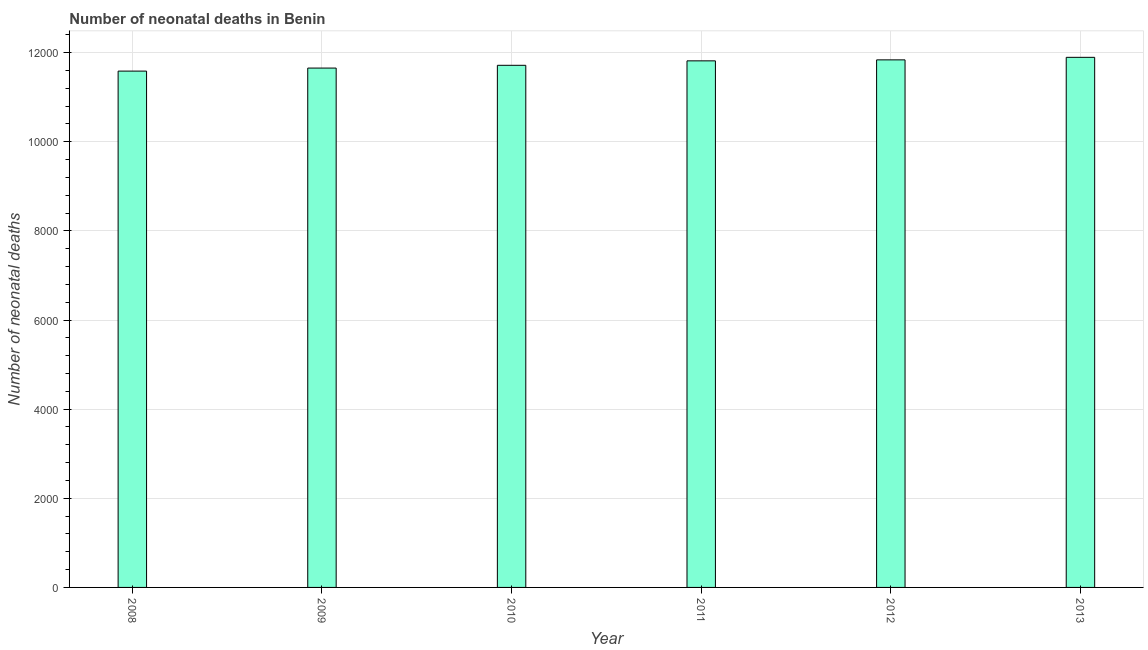Does the graph contain any zero values?
Offer a terse response. No. What is the title of the graph?
Your answer should be very brief. Number of neonatal deaths in Benin. What is the label or title of the Y-axis?
Give a very brief answer. Number of neonatal deaths. What is the number of neonatal deaths in 2010?
Offer a terse response. 1.17e+04. Across all years, what is the maximum number of neonatal deaths?
Offer a very short reply. 1.19e+04. Across all years, what is the minimum number of neonatal deaths?
Keep it short and to the point. 1.16e+04. In which year was the number of neonatal deaths minimum?
Keep it short and to the point. 2008. What is the sum of the number of neonatal deaths?
Provide a short and direct response. 7.05e+04. What is the difference between the number of neonatal deaths in 2011 and 2013?
Offer a terse response. -79. What is the average number of neonatal deaths per year?
Keep it short and to the point. 1.18e+04. What is the median number of neonatal deaths?
Your response must be concise. 1.18e+04. What is the ratio of the number of neonatal deaths in 2010 to that in 2013?
Ensure brevity in your answer.  0.98. Is the difference between the number of neonatal deaths in 2008 and 2013 greater than the difference between any two years?
Keep it short and to the point. Yes. What is the difference between the highest and the second highest number of neonatal deaths?
Offer a terse response. 57. What is the difference between the highest and the lowest number of neonatal deaths?
Your response must be concise. 309. In how many years, is the number of neonatal deaths greater than the average number of neonatal deaths taken over all years?
Make the answer very short. 3. Are all the bars in the graph horizontal?
Offer a very short reply. No. What is the difference between two consecutive major ticks on the Y-axis?
Give a very brief answer. 2000. What is the Number of neonatal deaths of 2008?
Your answer should be very brief. 1.16e+04. What is the Number of neonatal deaths in 2009?
Offer a terse response. 1.17e+04. What is the Number of neonatal deaths in 2010?
Provide a short and direct response. 1.17e+04. What is the Number of neonatal deaths of 2011?
Your answer should be very brief. 1.18e+04. What is the Number of neonatal deaths in 2012?
Offer a very short reply. 1.18e+04. What is the Number of neonatal deaths of 2013?
Provide a succinct answer. 1.19e+04. What is the difference between the Number of neonatal deaths in 2008 and 2009?
Ensure brevity in your answer.  -68. What is the difference between the Number of neonatal deaths in 2008 and 2010?
Give a very brief answer. -130. What is the difference between the Number of neonatal deaths in 2008 and 2011?
Your response must be concise. -230. What is the difference between the Number of neonatal deaths in 2008 and 2012?
Offer a terse response. -252. What is the difference between the Number of neonatal deaths in 2008 and 2013?
Make the answer very short. -309. What is the difference between the Number of neonatal deaths in 2009 and 2010?
Ensure brevity in your answer.  -62. What is the difference between the Number of neonatal deaths in 2009 and 2011?
Provide a short and direct response. -162. What is the difference between the Number of neonatal deaths in 2009 and 2012?
Offer a very short reply. -184. What is the difference between the Number of neonatal deaths in 2009 and 2013?
Ensure brevity in your answer.  -241. What is the difference between the Number of neonatal deaths in 2010 and 2011?
Ensure brevity in your answer.  -100. What is the difference between the Number of neonatal deaths in 2010 and 2012?
Give a very brief answer. -122. What is the difference between the Number of neonatal deaths in 2010 and 2013?
Offer a terse response. -179. What is the difference between the Number of neonatal deaths in 2011 and 2013?
Your answer should be very brief. -79. What is the difference between the Number of neonatal deaths in 2012 and 2013?
Give a very brief answer. -57. What is the ratio of the Number of neonatal deaths in 2008 to that in 2009?
Make the answer very short. 0.99. What is the ratio of the Number of neonatal deaths in 2008 to that in 2011?
Make the answer very short. 0.98. What is the ratio of the Number of neonatal deaths in 2008 to that in 2013?
Ensure brevity in your answer.  0.97. What is the ratio of the Number of neonatal deaths in 2009 to that in 2010?
Your answer should be compact. 0.99. What is the ratio of the Number of neonatal deaths in 2009 to that in 2011?
Offer a very short reply. 0.99. What is the ratio of the Number of neonatal deaths in 2009 to that in 2012?
Provide a succinct answer. 0.98. What is the ratio of the Number of neonatal deaths in 2012 to that in 2013?
Make the answer very short. 0.99. 